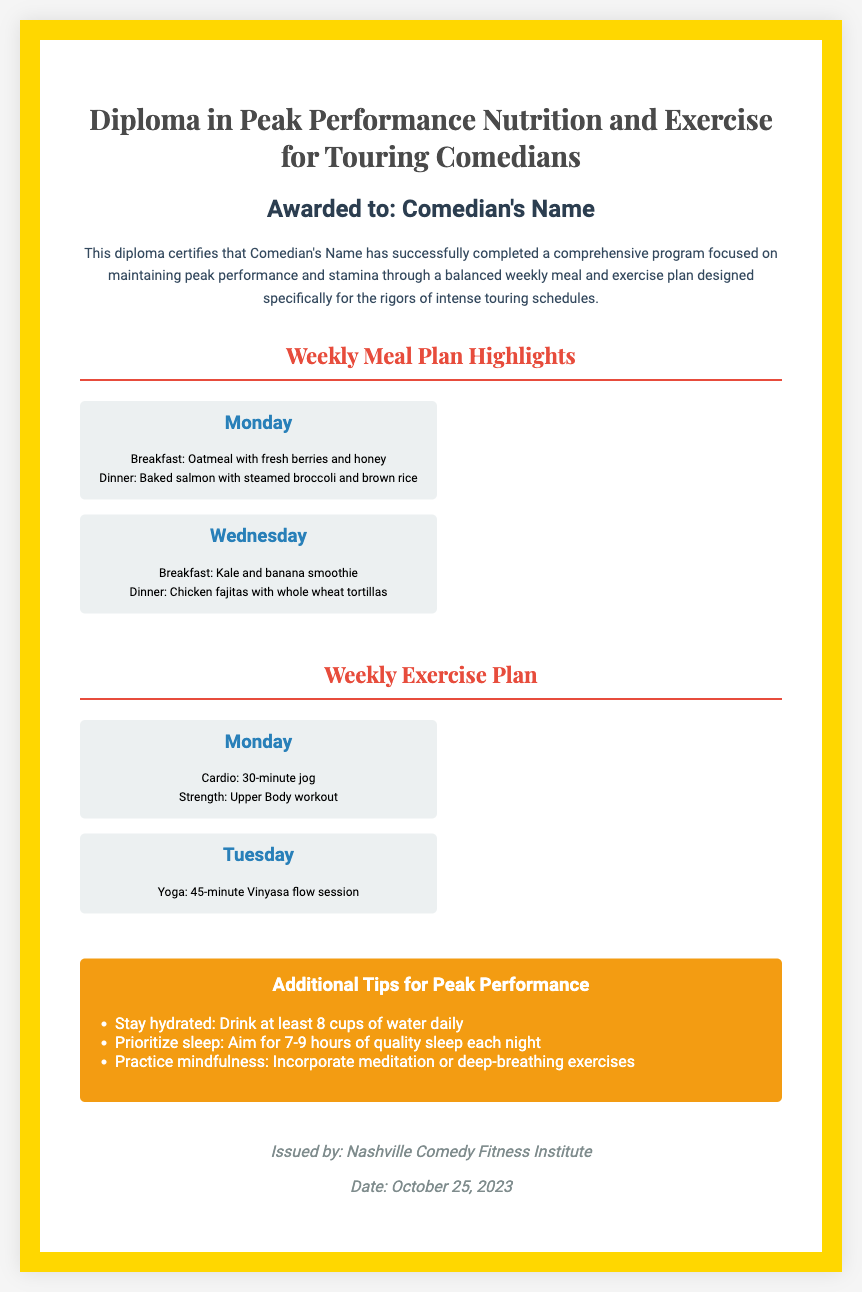What is the title of the diploma? The title of the diploma is prominently displayed at the top of the document.
Answer: Diploma in Peak Performance Nutrition and Exercise for Touring Comedians Who is the recipient of the diploma? The recipient's name is indicated under the "Awarded to" section.
Answer: Comedian's Name What is one of the breakfast options listed for Monday's meal plan? The document specifies the breakfast choice for Monday within the weekly meal plan section.
Answer: Oatmeal with fresh berries and honey How long is the cardio session on Monday? The duration of the cardio session for Monday is detailed in the weekly exercise plan.
Answer: 30-minute What is one additional tip for maintaining peak performance? The document highlights various tips for peak performance in a specific section.
Answer: Stay hydrated: Drink at least 8 cups of water daily What date was the diploma issued? The issuance date is noted at the end of the document, before the signature section.
Answer: October 25, 2023 How many hours of sleep should be prioritized each night? The recommendation for sleep duration is included in the tips for peak performance.
Answer: 7-9 hours What type of workout is included on Tuesday? The document lists the various exercises planned for Tuesday in the exercise section.
Answer: Yoga: 45-minute Vinyasa flow session 